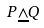Convert formula to latex. <formula><loc_0><loc_0><loc_500><loc_500>P \underline { \wedge } Q</formula> 